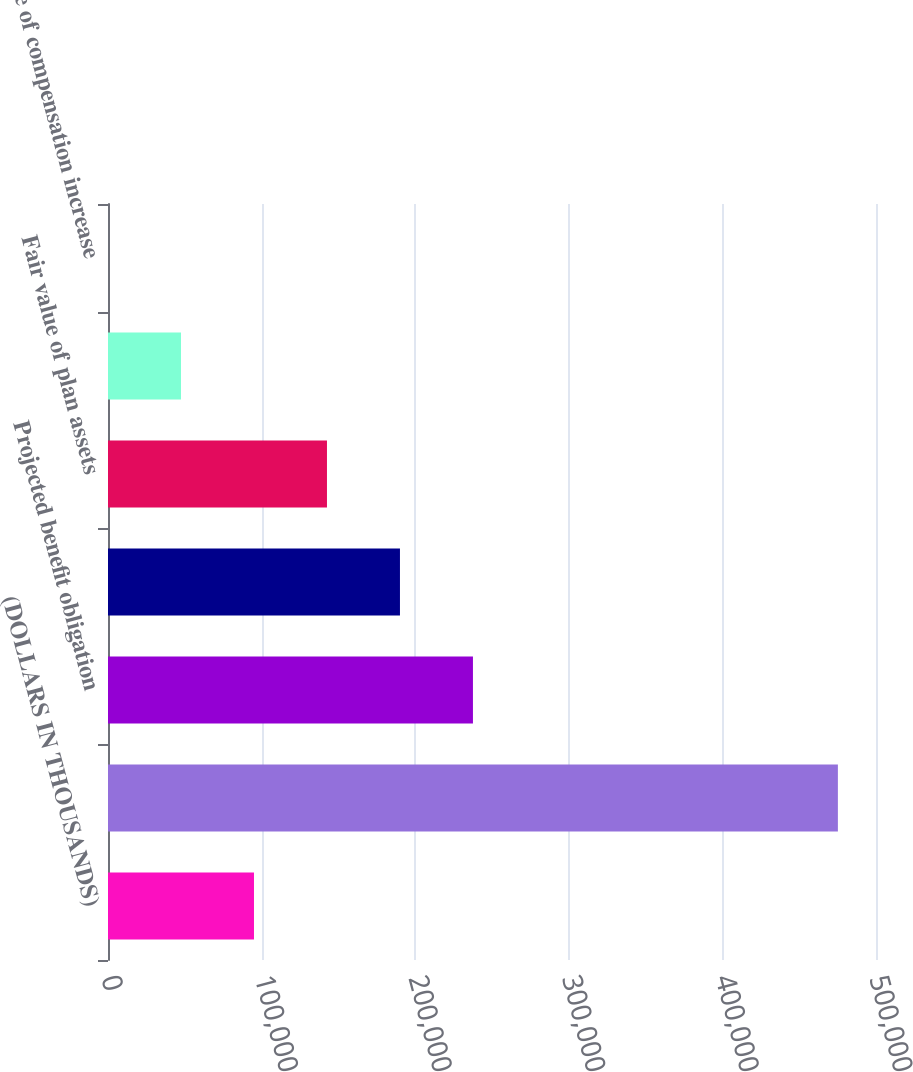<chart> <loc_0><loc_0><loc_500><loc_500><bar_chart><fcel>(DOLLARS IN THOUSANDS)<fcel>Accumulated Benefit Obligation<fcel>Projected benefit obligation<fcel>Accumulated benefit obligation<fcel>Fair value of plan assets<fcel>Discount rate<fcel>Rate of compensation increase<nl><fcel>95039.8<fcel>475189<fcel>237596<fcel>190077<fcel>142558<fcel>47521.2<fcel>2.56<nl></chart> 